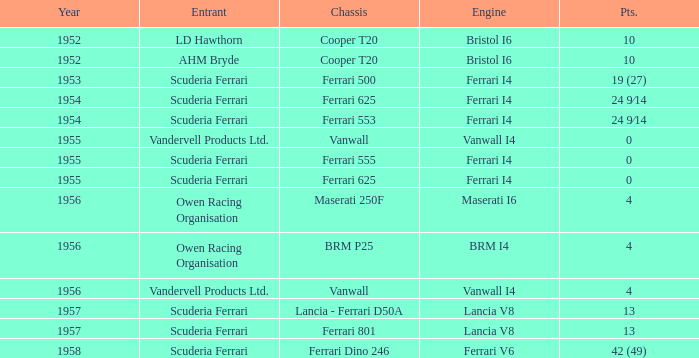Which entrant has 4 points and BRM p25 for the Chassis? Owen Racing Organisation. 